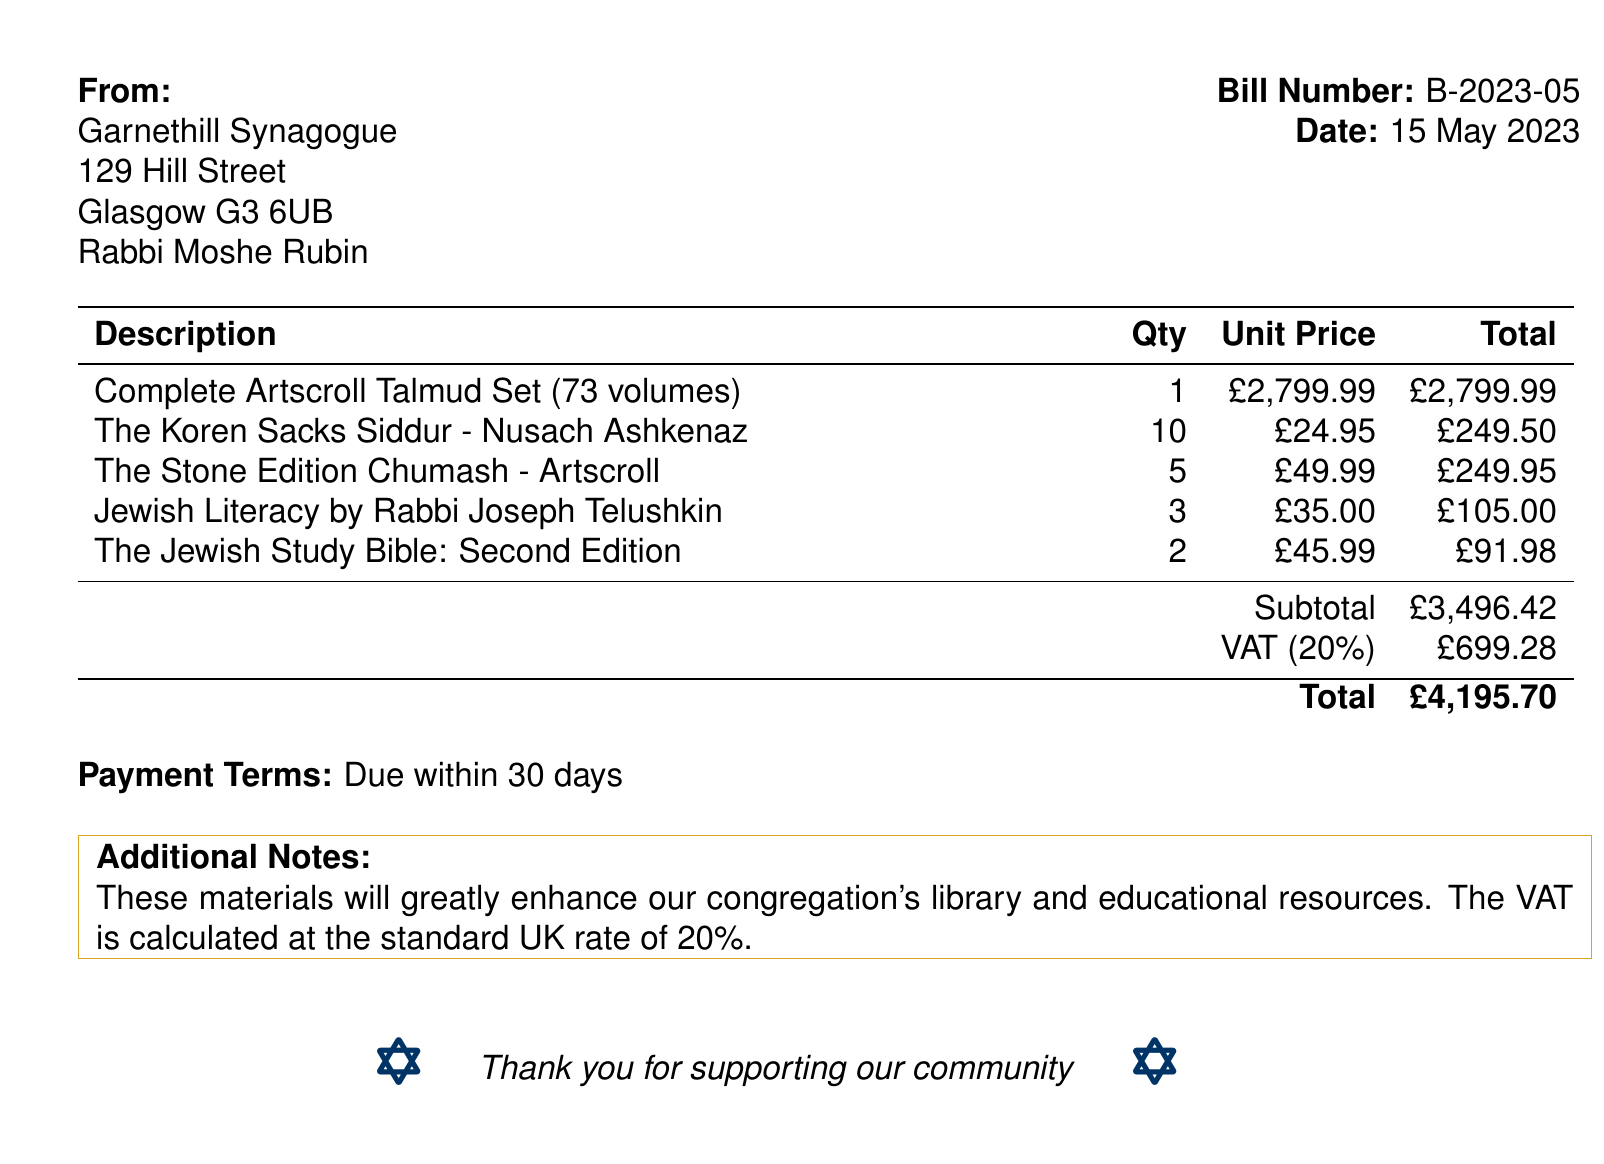What is the bill number? The bill number is listed prominently in the document as a unique identifier for the bill.
Answer: B-2023-05 What is the date of the bill? The date is provided next to the bill number, indicating when the bill was issued.
Answer: 15 May 2023 Who is the Rabbi associated with this bill? The Rabbi's name is mentioned at the top of the document as the contact person for the synagogue.
Answer: Rabbi Moshe Rubin What is the subtotal amount before VAT? The subtotal is the sum of the costs before the VAT is added, as indicated in the detailed cost table.
Answer: £3,496.42 How many volumes are in the Complete Artscroll Talmud Set? The description of the Complete Artscroll Talmud Set includes the total number of volumes it contains.
Answer: 73 volumes What is the total amount due including VAT? The total amount is calculated and shown at the bottom of the document, representing the complete cost including VAT.
Answer: £4,195.70 What is the VAT rate applied in this bill? The VAT rate is a standard percentage applied on the subtotal, as indicated in the document.
Answer: 20% What payment terms are specified in the bill? The payment terms set out when the payment should be made after the bill date.
Answer: Due within 30 days What is the total quantity of The Koren Sacks Siddur ordered? The quantity ordered for The Koren Sacks Siddur is specified in the table with other items.
Answer: 10 